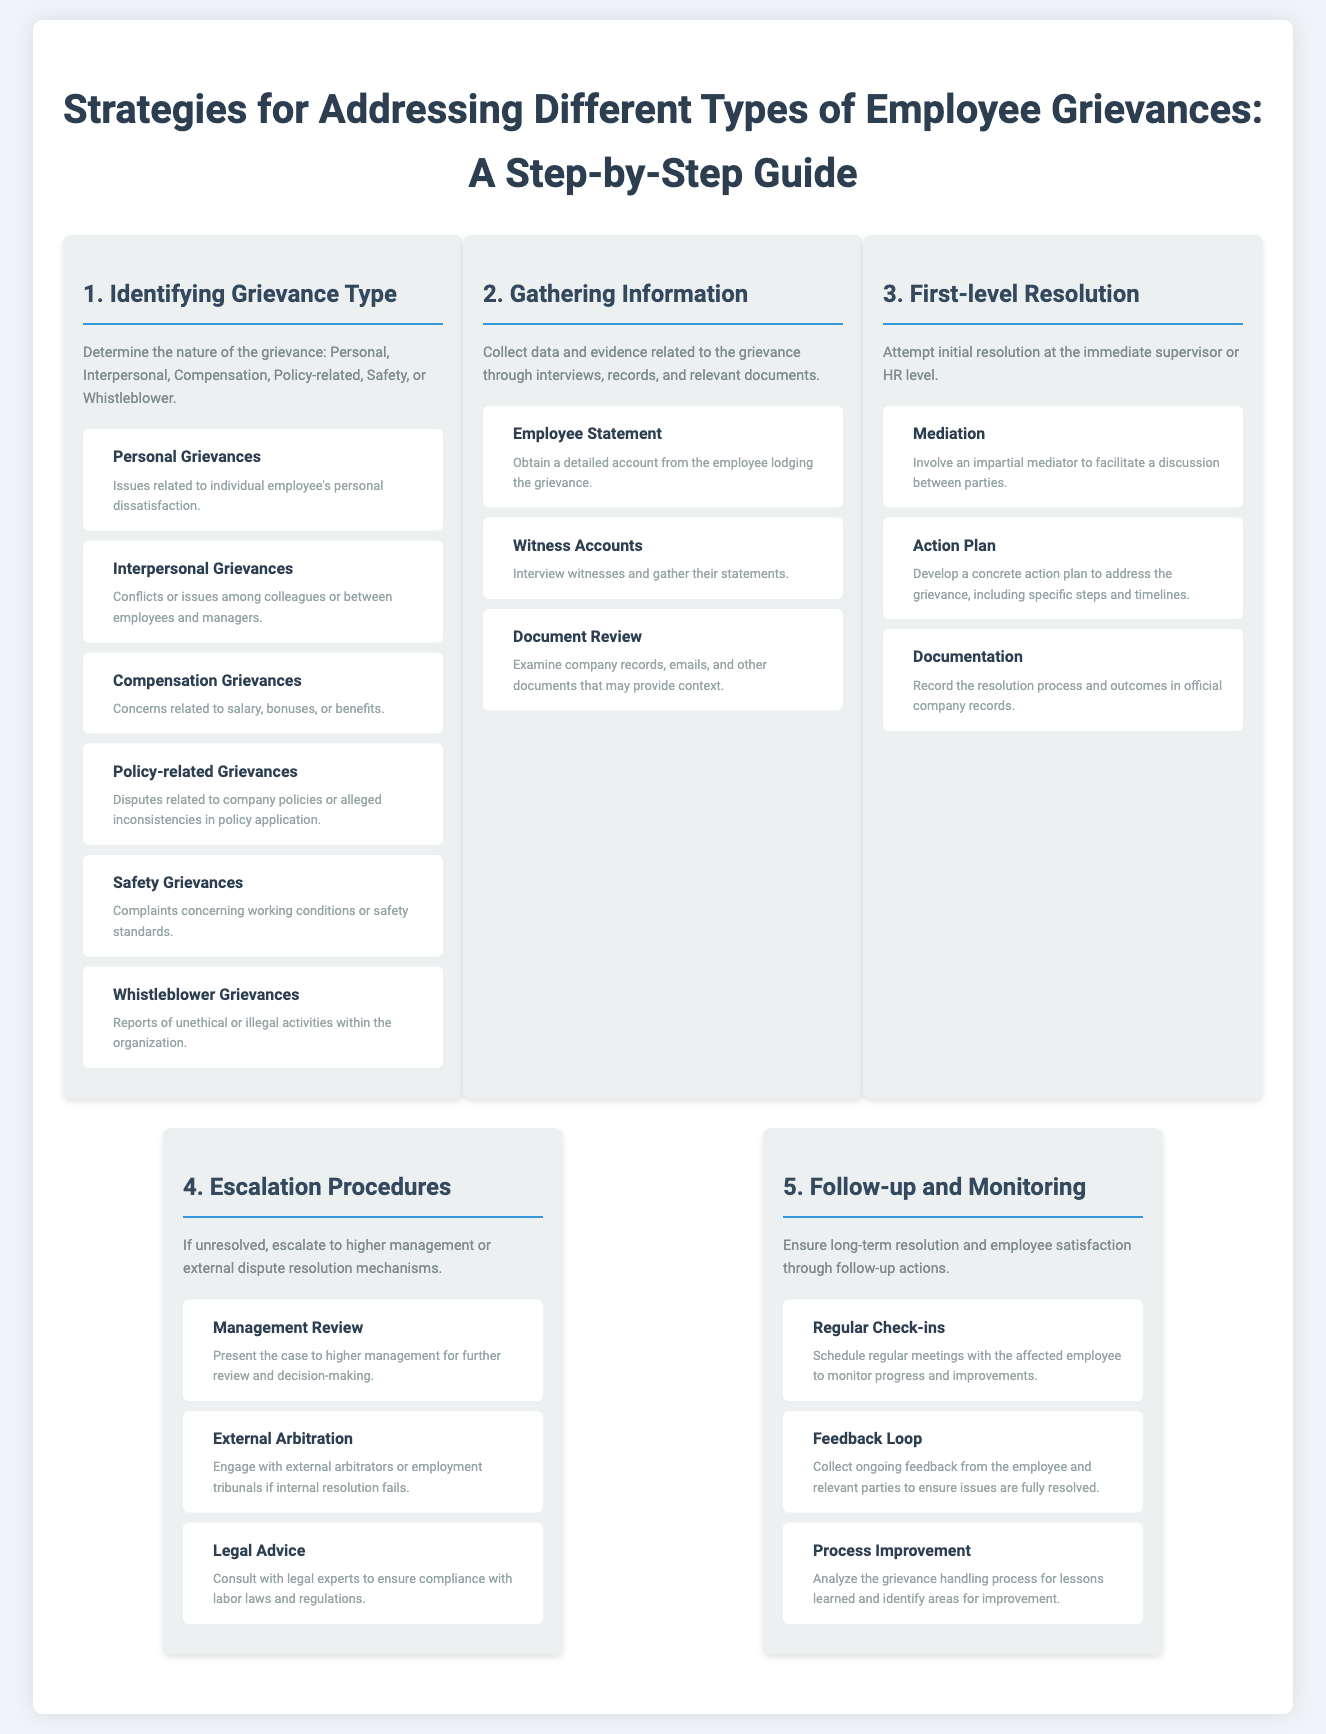What are the types of grievances? The document lists six types of grievances: Personal, Interpersonal, Compensation, Policy-related, Safety, or Whistleblower.
Answer: Personal, Interpersonal, Compensation, Policy-related, Safety, Whistleblower What is the first step in addressing grievances? The first step in addressing grievances as per the document is to identify the grievance type.
Answer: Identifying Grievance Type What is one action to take during the First-level Resolution step? One action listed under the First-level Resolution step is to develop a concrete action plan.
Answer: Action Plan How many sub-steps are included in the Gathering Information step? The Gathering Information step includes three sub-steps according to the document.
Answer: Three What should be done if the grievance remains unresolved? If unresolved, the document suggests escalating to higher management or external dispute resolution mechanisms.
Answer: Escalation Procedures What is the purpose of the Follow-up and Monitoring step? The purpose of this step is to ensure long-term resolution and employee satisfaction.
Answer: Long-term resolution and employee satisfaction What role does mediation play? Mediation involves an impartial mediator to facilitate a discussion between parties.
Answer: Facilitate discussion Who should be consulted to ensure legal compliance? The document advises consulting with legal experts to ensure compliance with labor laws and regulations.
Answer: Legal experts 